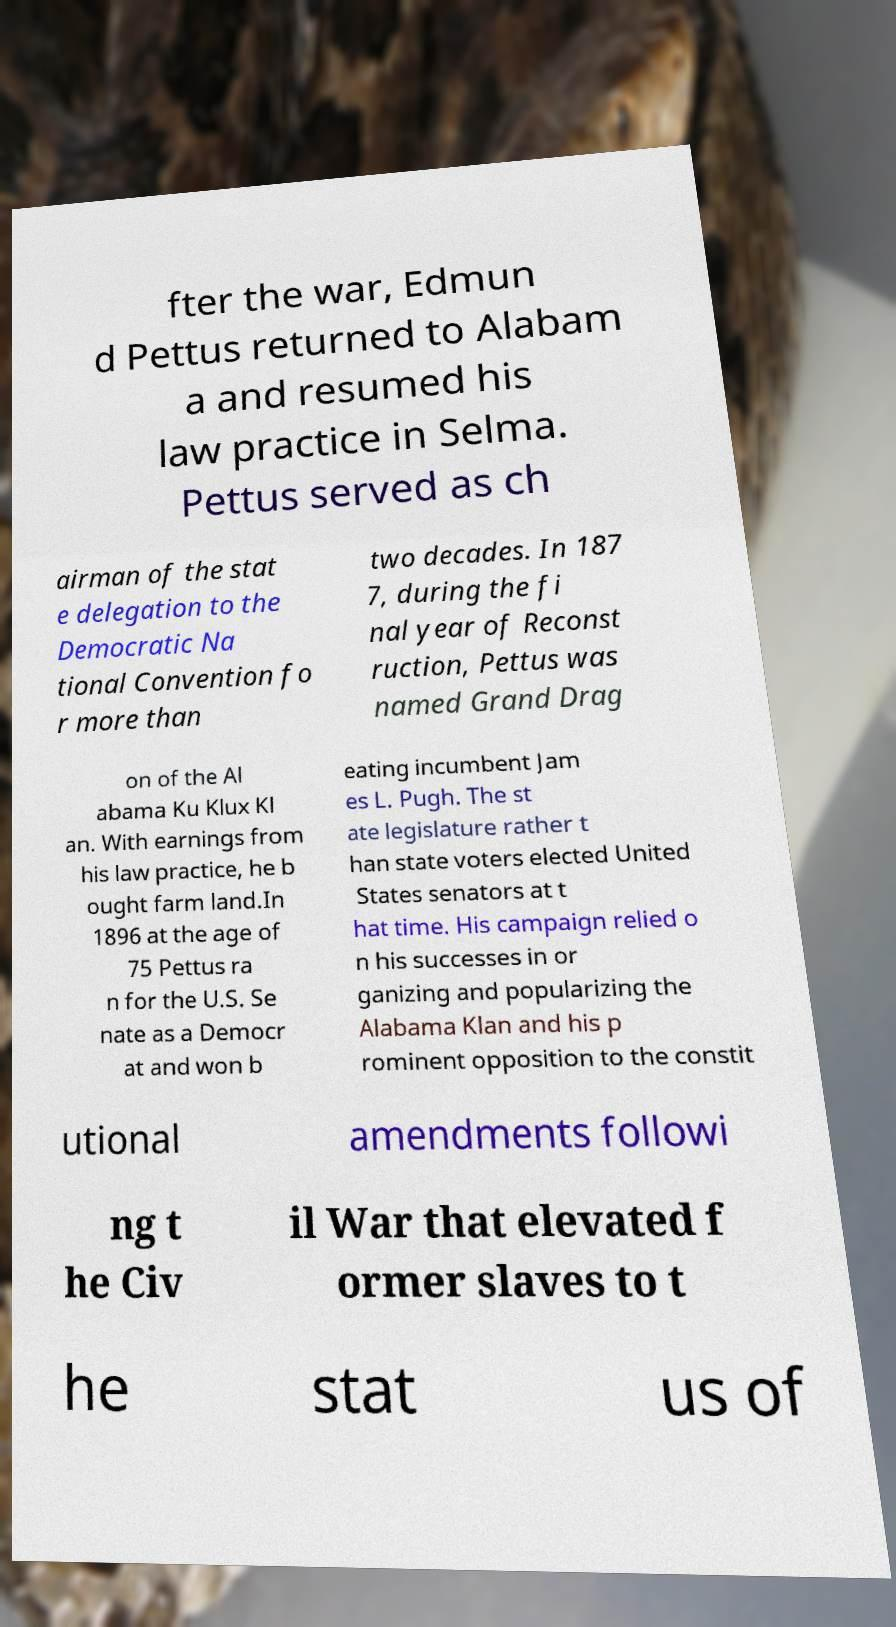I need the written content from this picture converted into text. Can you do that? fter the war, Edmun d Pettus returned to Alabam a and resumed his law practice in Selma. Pettus served as ch airman of the stat e delegation to the Democratic Na tional Convention fo r more than two decades. In 187 7, during the fi nal year of Reconst ruction, Pettus was named Grand Drag on of the Al abama Ku Klux Kl an. With earnings from his law practice, he b ought farm land.In 1896 at the age of 75 Pettus ra n for the U.S. Se nate as a Democr at and won b eating incumbent Jam es L. Pugh. The st ate legislature rather t han state voters elected United States senators at t hat time. His campaign relied o n his successes in or ganizing and popularizing the Alabama Klan and his p rominent opposition to the constit utional amendments followi ng t he Civ il War that elevated f ormer slaves to t he stat us of 